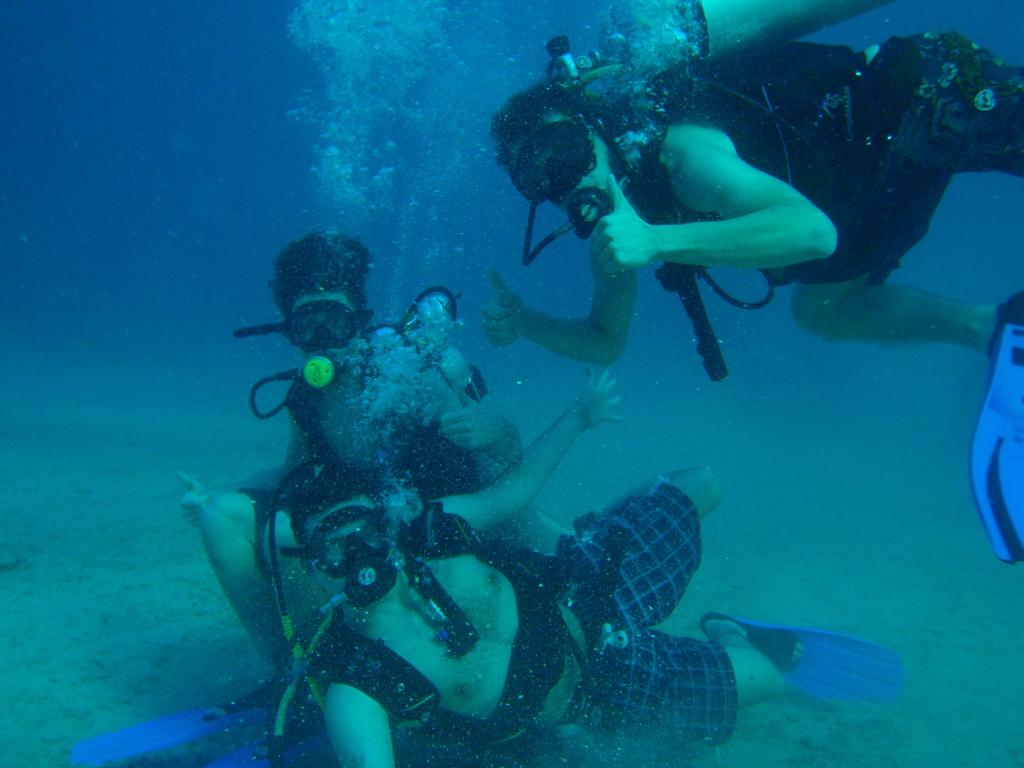How many people are in the image? There are three persons in the image. What are the persons doing in the image? The persons are swimming in the water. What type of ladybug can be seen floating on the surface of the water in the image? There is no ladybug present in the image; the persons are swimming in the water. 